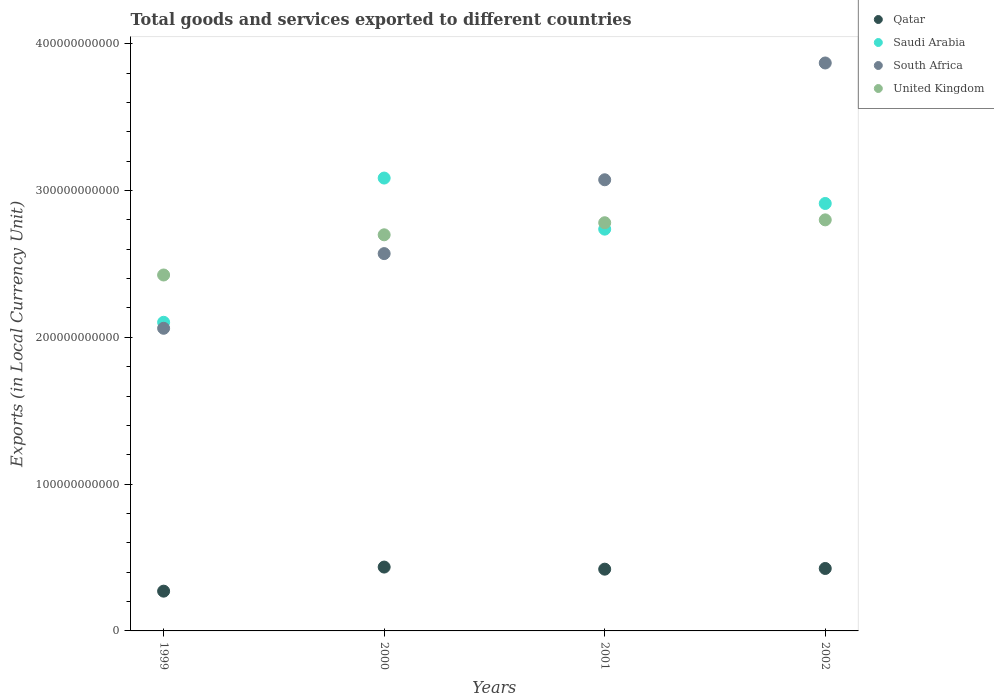Is the number of dotlines equal to the number of legend labels?
Make the answer very short. Yes. What is the Amount of goods and services exports in South Africa in 1999?
Offer a terse response. 2.06e+11. Across all years, what is the maximum Amount of goods and services exports in Saudi Arabia?
Ensure brevity in your answer.  3.08e+11. Across all years, what is the minimum Amount of goods and services exports in South Africa?
Your answer should be very brief. 2.06e+11. In which year was the Amount of goods and services exports in Saudi Arabia minimum?
Your response must be concise. 1999. What is the total Amount of goods and services exports in Qatar in the graph?
Offer a very short reply. 1.55e+11. What is the difference between the Amount of goods and services exports in Qatar in 2000 and that in 2001?
Give a very brief answer. 1.43e+09. What is the difference between the Amount of goods and services exports in Saudi Arabia in 1999 and the Amount of goods and services exports in United Kingdom in 2001?
Provide a succinct answer. -6.78e+1. What is the average Amount of goods and services exports in Qatar per year?
Ensure brevity in your answer.  3.88e+1. In the year 1999, what is the difference between the Amount of goods and services exports in South Africa and Amount of goods and services exports in Saudi Arabia?
Provide a short and direct response. -4.09e+09. In how many years, is the Amount of goods and services exports in South Africa greater than 220000000000 LCU?
Offer a terse response. 3. What is the ratio of the Amount of goods and services exports in South Africa in 1999 to that in 2000?
Give a very brief answer. 0.8. Is the Amount of goods and services exports in South Africa in 1999 less than that in 2000?
Give a very brief answer. Yes. What is the difference between the highest and the second highest Amount of goods and services exports in Saudi Arabia?
Keep it short and to the point. 1.73e+1. What is the difference between the highest and the lowest Amount of goods and services exports in Qatar?
Offer a very short reply. 1.64e+1. Is it the case that in every year, the sum of the Amount of goods and services exports in United Kingdom and Amount of goods and services exports in Saudi Arabia  is greater than the Amount of goods and services exports in Qatar?
Keep it short and to the point. Yes. Is the Amount of goods and services exports in Saudi Arabia strictly greater than the Amount of goods and services exports in Qatar over the years?
Your answer should be very brief. Yes. How many dotlines are there?
Offer a very short reply. 4. What is the difference between two consecutive major ticks on the Y-axis?
Keep it short and to the point. 1.00e+11. Does the graph contain any zero values?
Your answer should be compact. No. Does the graph contain grids?
Make the answer very short. No. Where does the legend appear in the graph?
Keep it short and to the point. Top right. How are the legend labels stacked?
Provide a short and direct response. Vertical. What is the title of the graph?
Your answer should be compact. Total goods and services exported to different countries. Does "Colombia" appear as one of the legend labels in the graph?
Offer a very short reply. No. What is the label or title of the X-axis?
Keep it short and to the point. Years. What is the label or title of the Y-axis?
Your answer should be very brief. Exports (in Local Currency Unit). What is the Exports (in Local Currency Unit) in Qatar in 1999?
Offer a very short reply. 2.71e+1. What is the Exports (in Local Currency Unit) in Saudi Arabia in 1999?
Offer a terse response. 2.10e+11. What is the Exports (in Local Currency Unit) in South Africa in 1999?
Your answer should be very brief. 2.06e+11. What is the Exports (in Local Currency Unit) of United Kingdom in 1999?
Provide a succinct answer. 2.42e+11. What is the Exports (in Local Currency Unit) in Qatar in 2000?
Provide a succinct answer. 4.35e+1. What is the Exports (in Local Currency Unit) in Saudi Arabia in 2000?
Your answer should be compact. 3.08e+11. What is the Exports (in Local Currency Unit) of South Africa in 2000?
Offer a terse response. 2.57e+11. What is the Exports (in Local Currency Unit) of United Kingdom in 2000?
Your response must be concise. 2.70e+11. What is the Exports (in Local Currency Unit) of Qatar in 2001?
Keep it short and to the point. 4.21e+1. What is the Exports (in Local Currency Unit) in Saudi Arabia in 2001?
Offer a terse response. 2.74e+11. What is the Exports (in Local Currency Unit) in South Africa in 2001?
Provide a succinct answer. 3.07e+11. What is the Exports (in Local Currency Unit) in United Kingdom in 2001?
Ensure brevity in your answer.  2.78e+11. What is the Exports (in Local Currency Unit) of Qatar in 2002?
Your answer should be compact. 4.25e+1. What is the Exports (in Local Currency Unit) in Saudi Arabia in 2002?
Offer a very short reply. 2.91e+11. What is the Exports (in Local Currency Unit) in South Africa in 2002?
Offer a very short reply. 3.87e+11. What is the Exports (in Local Currency Unit) in United Kingdom in 2002?
Make the answer very short. 2.80e+11. Across all years, what is the maximum Exports (in Local Currency Unit) in Qatar?
Your response must be concise. 4.35e+1. Across all years, what is the maximum Exports (in Local Currency Unit) of Saudi Arabia?
Your answer should be compact. 3.08e+11. Across all years, what is the maximum Exports (in Local Currency Unit) of South Africa?
Ensure brevity in your answer.  3.87e+11. Across all years, what is the maximum Exports (in Local Currency Unit) in United Kingdom?
Ensure brevity in your answer.  2.80e+11. Across all years, what is the minimum Exports (in Local Currency Unit) in Qatar?
Offer a very short reply. 2.71e+1. Across all years, what is the minimum Exports (in Local Currency Unit) in Saudi Arabia?
Your answer should be compact. 2.10e+11. Across all years, what is the minimum Exports (in Local Currency Unit) in South Africa?
Your response must be concise. 2.06e+11. Across all years, what is the minimum Exports (in Local Currency Unit) of United Kingdom?
Your answer should be very brief. 2.42e+11. What is the total Exports (in Local Currency Unit) of Qatar in the graph?
Provide a short and direct response. 1.55e+11. What is the total Exports (in Local Currency Unit) of Saudi Arabia in the graph?
Offer a terse response. 1.08e+12. What is the total Exports (in Local Currency Unit) of South Africa in the graph?
Provide a succinct answer. 1.16e+12. What is the total Exports (in Local Currency Unit) in United Kingdom in the graph?
Give a very brief answer. 1.07e+12. What is the difference between the Exports (in Local Currency Unit) in Qatar in 1999 and that in 2000?
Offer a very short reply. -1.64e+1. What is the difference between the Exports (in Local Currency Unit) in Saudi Arabia in 1999 and that in 2000?
Provide a succinct answer. -9.82e+1. What is the difference between the Exports (in Local Currency Unit) in South Africa in 1999 and that in 2000?
Provide a short and direct response. -5.09e+1. What is the difference between the Exports (in Local Currency Unit) in United Kingdom in 1999 and that in 2000?
Provide a succinct answer. -2.74e+1. What is the difference between the Exports (in Local Currency Unit) in Qatar in 1999 and that in 2001?
Provide a succinct answer. -1.50e+1. What is the difference between the Exports (in Local Currency Unit) in Saudi Arabia in 1999 and that in 2001?
Give a very brief answer. -6.34e+1. What is the difference between the Exports (in Local Currency Unit) of South Africa in 1999 and that in 2001?
Make the answer very short. -1.01e+11. What is the difference between the Exports (in Local Currency Unit) of United Kingdom in 1999 and that in 2001?
Your answer should be very brief. -3.56e+1. What is the difference between the Exports (in Local Currency Unit) of Qatar in 1999 and that in 2002?
Offer a terse response. -1.54e+1. What is the difference between the Exports (in Local Currency Unit) in Saudi Arabia in 1999 and that in 2002?
Give a very brief answer. -8.09e+1. What is the difference between the Exports (in Local Currency Unit) in South Africa in 1999 and that in 2002?
Provide a succinct answer. -1.81e+11. What is the difference between the Exports (in Local Currency Unit) in United Kingdom in 1999 and that in 2002?
Offer a very short reply. -3.76e+1. What is the difference between the Exports (in Local Currency Unit) of Qatar in 2000 and that in 2001?
Offer a terse response. 1.43e+09. What is the difference between the Exports (in Local Currency Unit) in Saudi Arabia in 2000 and that in 2001?
Your answer should be compact. 3.48e+1. What is the difference between the Exports (in Local Currency Unit) of South Africa in 2000 and that in 2001?
Provide a short and direct response. -5.03e+1. What is the difference between the Exports (in Local Currency Unit) of United Kingdom in 2000 and that in 2001?
Provide a short and direct response. -8.22e+09. What is the difference between the Exports (in Local Currency Unit) in Qatar in 2000 and that in 2002?
Offer a very short reply. 9.64e+08. What is the difference between the Exports (in Local Currency Unit) of Saudi Arabia in 2000 and that in 2002?
Offer a terse response. 1.73e+1. What is the difference between the Exports (in Local Currency Unit) of South Africa in 2000 and that in 2002?
Your answer should be compact. -1.30e+11. What is the difference between the Exports (in Local Currency Unit) of United Kingdom in 2000 and that in 2002?
Provide a succinct answer. -1.02e+1. What is the difference between the Exports (in Local Currency Unit) of Qatar in 2001 and that in 2002?
Give a very brief answer. -4.66e+08. What is the difference between the Exports (in Local Currency Unit) of Saudi Arabia in 2001 and that in 2002?
Offer a terse response. -1.75e+1. What is the difference between the Exports (in Local Currency Unit) of South Africa in 2001 and that in 2002?
Give a very brief answer. -7.96e+1. What is the difference between the Exports (in Local Currency Unit) in United Kingdom in 2001 and that in 2002?
Give a very brief answer. -1.96e+09. What is the difference between the Exports (in Local Currency Unit) in Qatar in 1999 and the Exports (in Local Currency Unit) in Saudi Arabia in 2000?
Provide a short and direct response. -2.81e+11. What is the difference between the Exports (in Local Currency Unit) in Qatar in 1999 and the Exports (in Local Currency Unit) in South Africa in 2000?
Provide a short and direct response. -2.30e+11. What is the difference between the Exports (in Local Currency Unit) of Qatar in 1999 and the Exports (in Local Currency Unit) of United Kingdom in 2000?
Provide a succinct answer. -2.43e+11. What is the difference between the Exports (in Local Currency Unit) in Saudi Arabia in 1999 and the Exports (in Local Currency Unit) in South Africa in 2000?
Give a very brief answer. -4.68e+1. What is the difference between the Exports (in Local Currency Unit) of Saudi Arabia in 1999 and the Exports (in Local Currency Unit) of United Kingdom in 2000?
Ensure brevity in your answer.  -5.96e+1. What is the difference between the Exports (in Local Currency Unit) in South Africa in 1999 and the Exports (in Local Currency Unit) in United Kingdom in 2000?
Offer a very short reply. -6.37e+1. What is the difference between the Exports (in Local Currency Unit) in Qatar in 1999 and the Exports (in Local Currency Unit) in Saudi Arabia in 2001?
Give a very brief answer. -2.47e+11. What is the difference between the Exports (in Local Currency Unit) of Qatar in 1999 and the Exports (in Local Currency Unit) of South Africa in 2001?
Make the answer very short. -2.80e+11. What is the difference between the Exports (in Local Currency Unit) of Qatar in 1999 and the Exports (in Local Currency Unit) of United Kingdom in 2001?
Provide a short and direct response. -2.51e+11. What is the difference between the Exports (in Local Currency Unit) of Saudi Arabia in 1999 and the Exports (in Local Currency Unit) of South Africa in 2001?
Your answer should be compact. -9.71e+1. What is the difference between the Exports (in Local Currency Unit) of Saudi Arabia in 1999 and the Exports (in Local Currency Unit) of United Kingdom in 2001?
Offer a very short reply. -6.78e+1. What is the difference between the Exports (in Local Currency Unit) in South Africa in 1999 and the Exports (in Local Currency Unit) in United Kingdom in 2001?
Provide a short and direct response. -7.19e+1. What is the difference between the Exports (in Local Currency Unit) in Qatar in 1999 and the Exports (in Local Currency Unit) in Saudi Arabia in 2002?
Provide a succinct answer. -2.64e+11. What is the difference between the Exports (in Local Currency Unit) of Qatar in 1999 and the Exports (in Local Currency Unit) of South Africa in 2002?
Your answer should be very brief. -3.60e+11. What is the difference between the Exports (in Local Currency Unit) in Qatar in 1999 and the Exports (in Local Currency Unit) in United Kingdom in 2002?
Your answer should be very brief. -2.53e+11. What is the difference between the Exports (in Local Currency Unit) in Saudi Arabia in 1999 and the Exports (in Local Currency Unit) in South Africa in 2002?
Offer a very short reply. -1.77e+11. What is the difference between the Exports (in Local Currency Unit) in Saudi Arabia in 1999 and the Exports (in Local Currency Unit) in United Kingdom in 2002?
Give a very brief answer. -6.98e+1. What is the difference between the Exports (in Local Currency Unit) in South Africa in 1999 and the Exports (in Local Currency Unit) in United Kingdom in 2002?
Offer a terse response. -7.39e+1. What is the difference between the Exports (in Local Currency Unit) of Qatar in 2000 and the Exports (in Local Currency Unit) of Saudi Arabia in 2001?
Your answer should be compact. -2.30e+11. What is the difference between the Exports (in Local Currency Unit) of Qatar in 2000 and the Exports (in Local Currency Unit) of South Africa in 2001?
Your answer should be very brief. -2.64e+11. What is the difference between the Exports (in Local Currency Unit) in Qatar in 2000 and the Exports (in Local Currency Unit) in United Kingdom in 2001?
Your answer should be compact. -2.35e+11. What is the difference between the Exports (in Local Currency Unit) in Saudi Arabia in 2000 and the Exports (in Local Currency Unit) in South Africa in 2001?
Your answer should be compact. 1.17e+09. What is the difference between the Exports (in Local Currency Unit) in Saudi Arabia in 2000 and the Exports (in Local Currency Unit) in United Kingdom in 2001?
Offer a very short reply. 3.04e+1. What is the difference between the Exports (in Local Currency Unit) in South Africa in 2000 and the Exports (in Local Currency Unit) in United Kingdom in 2001?
Offer a terse response. -2.10e+1. What is the difference between the Exports (in Local Currency Unit) in Qatar in 2000 and the Exports (in Local Currency Unit) in Saudi Arabia in 2002?
Your answer should be compact. -2.48e+11. What is the difference between the Exports (in Local Currency Unit) of Qatar in 2000 and the Exports (in Local Currency Unit) of South Africa in 2002?
Keep it short and to the point. -3.43e+11. What is the difference between the Exports (in Local Currency Unit) of Qatar in 2000 and the Exports (in Local Currency Unit) of United Kingdom in 2002?
Your answer should be compact. -2.37e+11. What is the difference between the Exports (in Local Currency Unit) of Saudi Arabia in 2000 and the Exports (in Local Currency Unit) of South Africa in 2002?
Offer a terse response. -7.84e+1. What is the difference between the Exports (in Local Currency Unit) of Saudi Arabia in 2000 and the Exports (in Local Currency Unit) of United Kingdom in 2002?
Your response must be concise. 2.85e+1. What is the difference between the Exports (in Local Currency Unit) in South Africa in 2000 and the Exports (in Local Currency Unit) in United Kingdom in 2002?
Provide a succinct answer. -2.30e+1. What is the difference between the Exports (in Local Currency Unit) of Qatar in 2001 and the Exports (in Local Currency Unit) of Saudi Arabia in 2002?
Make the answer very short. -2.49e+11. What is the difference between the Exports (in Local Currency Unit) of Qatar in 2001 and the Exports (in Local Currency Unit) of South Africa in 2002?
Offer a very short reply. -3.45e+11. What is the difference between the Exports (in Local Currency Unit) of Qatar in 2001 and the Exports (in Local Currency Unit) of United Kingdom in 2002?
Provide a short and direct response. -2.38e+11. What is the difference between the Exports (in Local Currency Unit) of Saudi Arabia in 2001 and the Exports (in Local Currency Unit) of South Africa in 2002?
Your response must be concise. -1.13e+11. What is the difference between the Exports (in Local Currency Unit) in Saudi Arabia in 2001 and the Exports (in Local Currency Unit) in United Kingdom in 2002?
Keep it short and to the point. -6.32e+09. What is the difference between the Exports (in Local Currency Unit) in South Africa in 2001 and the Exports (in Local Currency Unit) in United Kingdom in 2002?
Offer a very short reply. 2.73e+1. What is the average Exports (in Local Currency Unit) of Qatar per year?
Keep it short and to the point. 3.88e+1. What is the average Exports (in Local Currency Unit) of Saudi Arabia per year?
Make the answer very short. 2.71e+11. What is the average Exports (in Local Currency Unit) in South Africa per year?
Provide a short and direct response. 2.89e+11. What is the average Exports (in Local Currency Unit) in United Kingdom per year?
Provide a short and direct response. 2.68e+11. In the year 1999, what is the difference between the Exports (in Local Currency Unit) of Qatar and Exports (in Local Currency Unit) of Saudi Arabia?
Your answer should be very brief. -1.83e+11. In the year 1999, what is the difference between the Exports (in Local Currency Unit) in Qatar and Exports (in Local Currency Unit) in South Africa?
Keep it short and to the point. -1.79e+11. In the year 1999, what is the difference between the Exports (in Local Currency Unit) of Qatar and Exports (in Local Currency Unit) of United Kingdom?
Provide a succinct answer. -2.15e+11. In the year 1999, what is the difference between the Exports (in Local Currency Unit) of Saudi Arabia and Exports (in Local Currency Unit) of South Africa?
Offer a terse response. 4.09e+09. In the year 1999, what is the difference between the Exports (in Local Currency Unit) in Saudi Arabia and Exports (in Local Currency Unit) in United Kingdom?
Your response must be concise. -3.22e+1. In the year 1999, what is the difference between the Exports (in Local Currency Unit) of South Africa and Exports (in Local Currency Unit) of United Kingdom?
Your response must be concise. -3.63e+1. In the year 2000, what is the difference between the Exports (in Local Currency Unit) of Qatar and Exports (in Local Currency Unit) of Saudi Arabia?
Your answer should be compact. -2.65e+11. In the year 2000, what is the difference between the Exports (in Local Currency Unit) of Qatar and Exports (in Local Currency Unit) of South Africa?
Make the answer very short. -2.14e+11. In the year 2000, what is the difference between the Exports (in Local Currency Unit) in Qatar and Exports (in Local Currency Unit) in United Kingdom?
Give a very brief answer. -2.26e+11. In the year 2000, what is the difference between the Exports (in Local Currency Unit) in Saudi Arabia and Exports (in Local Currency Unit) in South Africa?
Offer a very short reply. 5.15e+1. In the year 2000, what is the difference between the Exports (in Local Currency Unit) of Saudi Arabia and Exports (in Local Currency Unit) of United Kingdom?
Ensure brevity in your answer.  3.86e+1. In the year 2000, what is the difference between the Exports (in Local Currency Unit) in South Africa and Exports (in Local Currency Unit) in United Kingdom?
Make the answer very short. -1.28e+1. In the year 2001, what is the difference between the Exports (in Local Currency Unit) in Qatar and Exports (in Local Currency Unit) in Saudi Arabia?
Your answer should be compact. -2.32e+11. In the year 2001, what is the difference between the Exports (in Local Currency Unit) in Qatar and Exports (in Local Currency Unit) in South Africa?
Offer a terse response. -2.65e+11. In the year 2001, what is the difference between the Exports (in Local Currency Unit) of Qatar and Exports (in Local Currency Unit) of United Kingdom?
Your response must be concise. -2.36e+11. In the year 2001, what is the difference between the Exports (in Local Currency Unit) of Saudi Arabia and Exports (in Local Currency Unit) of South Africa?
Give a very brief answer. -3.36e+1. In the year 2001, what is the difference between the Exports (in Local Currency Unit) in Saudi Arabia and Exports (in Local Currency Unit) in United Kingdom?
Keep it short and to the point. -4.36e+09. In the year 2001, what is the difference between the Exports (in Local Currency Unit) of South Africa and Exports (in Local Currency Unit) of United Kingdom?
Provide a succinct answer. 2.93e+1. In the year 2002, what is the difference between the Exports (in Local Currency Unit) of Qatar and Exports (in Local Currency Unit) of Saudi Arabia?
Provide a short and direct response. -2.49e+11. In the year 2002, what is the difference between the Exports (in Local Currency Unit) of Qatar and Exports (in Local Currency Unit) of South Africa?
Provide a short and direct response. -3.44e+11. In the year 2002, what is the difference between the Exports (in Local Currency Unit) of Qatar and Exports (in Local Currency Unit) of United Kingdom?
Your answer should be compact. -2.37e+11. In the year 2002, what is the difference between the Exports (in Local Currency Unit) in Saudi Arabia and Exports (in Local Currency Unit) in South Africa?
Your answer should be compact. -9.57e+1. In the year 2002, what is the difference between the Exports (in Local Currency Unit) in Saudi Arabia and Exports (in Local Currency Unit) in United Kingdom?
Your response must be concise. 1.12e+1. In the year 2002, what is the difference between the Exports (in Local Currency Unit) in South Africa and Exports (in Local Currency Unit) in United Kingdom?
Keep it short and to the point. 1.07e+11. What is the ratio of the Exports (in Local Currency Unit) in Qatar in 1999 to that in 2000?
Offer a terse response. 0.62. What is the ratio of the Exports (in Local Currency Unit) in Saudi Arabia in 1999 to that in 2000?
Your response must be concise. 0.68. What is the ratio of the Exports (in Local Currency Unit) in South Africa in 1999 to that in 2000?
Provide a succinct answer. 0.8. What is the ratio of the Exports (in Local Currency Unit) of United Kingdom in 1999 to that in 2000?
Keep it short and to the point. 0.9. What is the ratio of the Exports (in Local Currency Unit) in Qatar in 1999 to that in 2001?
Offer a terse response. 0.64. What is the ratio of the Exports (in Local Currency Unit) in Saudi Arabia in 1999 to that in 2001?
Provide a succinct answer. 0.77. What is the ratio of the Exports (in Local Currency Unit) of South Africa in 1999 to that in 2001?
Offer a terse response. 0.67. What is the ratio of the Exports (in Local Currency Unit) of United Kingdom in 1999 to that in 2001?
Provide a short and direct response. 0.87. What is the ratio of the Exports (in Local Currency Unit) of Qatar in 1999 to that in 2002?
Your response must be concise. 0.64. What is the ratio of the Exports (in Local Currency Unit) in Saudi Arabia in 1999 to that in 2002?
Your response must be concise. 0.72. What is the ratio of the Exports (in Local Currency Unit) of South Africa in 1999 to that in 2002?
Make the answer very short. 0.53. What is the ratio of the Exports (in Local Currency Unit) in United Kingdom in 1999 to that in 2002?
Offer a very short reply. 0.87. What is the ratio of the Exports (in Local Currency Unit) of Qatar in 2000 to that in 2001?
Keep it short and to the point. 1.03. What is the ratio of the Exports (in Local Currency Unit) in Saudi Arabia in 2000 to that in 2001?
Make the answer very short. 1.13. What is the ratio of the Exports (in Local Currency Unit) in South Africa in 2000 to that in 2001?
Make the answer very short. 0.84. What is the ratio of the Exports (in Local Currency Unit) of United Kingdom in 2000 to that in 2001?
Ensure brevity in your answer.  0.97. What is the ratio of the Exports (in Local Currency Unit) of Qatar in 2000 to that in 2002?
Your answer should be very brief. 1.02. What is the ratio of the Exports (in Local Currency Unit) of Saudi Arabia in 2000 to that in 2002?
Provide a succinct answer. 1.06. What is the ratio of the Exports (in Local Currency Unit) in South Africa in 2000 to that in 2002?
Your answer should be compact. 0.66. What is the ratio of the Exports (in Local Currency Unit) in United Kingdom in 2000 to that in 2002?
Your response must be concise. 0.96. What is the ratio of the Exports (in Local Currency Unit) in Qatar in 2001 to that in 2002?
Your answer should be compact. 0.99. What is the ratio of the Exports (in Local Currency Unit) of South Africa in 2001 to that in 2002?
Provide a succinct answer. 0.79. What is the ratio of the Exports (in Local Currency Unit) of United Kingdom in 2001 to that in 2002?
Offer a terse response. 0.99. What is the difference between the highest and the second highest Exports (in Local Currency Unit) of Qatar?
Give a very brief answer. 9.64e+08. What is the difference between the highest and the second highest Exports (in Local Currency Unit) of Saudi Arabia?
Your answer should be very brief. 1.73e+1. What is the difference between the highest and the second highest Exports (in Local Currency Unit) of South Africa?
Offer a very short reply. 7.96e+1. What is the difference between the highest and the second highest Exports (in Local Currency Unit) in United Kingdom?
Offer a very short reply. 1.96e+09. What is the difference between the highest and the lowest Exports (in Local Currency Unit) of Qatar?
Offer a very short reply. 1.64e+1. What is the difference between the highest and the lowest Exports (in Local Currency Unit) of Saudi Arabia?
Ensure brevity in your answer.  9.82e+1. What is the difference between the highest and the lowest Exports (in Local Currency Unit) of South Africa?
Offer a terse response. 1.81e+11. What is the difference between the highest and the lowest Exports (in Local Currency Unit) of United Kingdom?
Offer a terse response. 3.76e+1. 